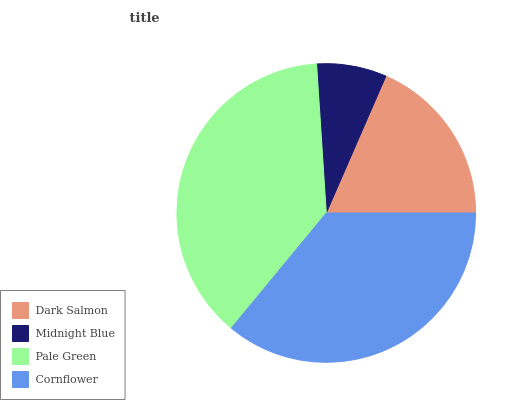Is Midnight Blue the minimum?
Answer yes or no. Yes. Is Pale Green the maximum?
Answer yes or no. Yes. Is Pale Green the minimum?
Answer yes or no. No. Is Midnight Blue the maximum?
Answer yes or no. No. Is Pale Green greater than Midnight Blue?
Answer yes or no. Yes. Is Midnight Blue less than Pale Green?
Answer yes or no. Yes. Is Midnight Blue greater than Pale Green?
Answer yes or no. No. Is Pale Green less than Midnight Blue?
Answer yes or no. No. Is Cornflower the high median?
Answer yes or no. Yes. Is Dark Salmon the low median?
Answer yes or no. Yes. Is Dark Salmon the high median?
Answer yes or no. No. Is Pale Green the low median?
Answer yes or no. No. 